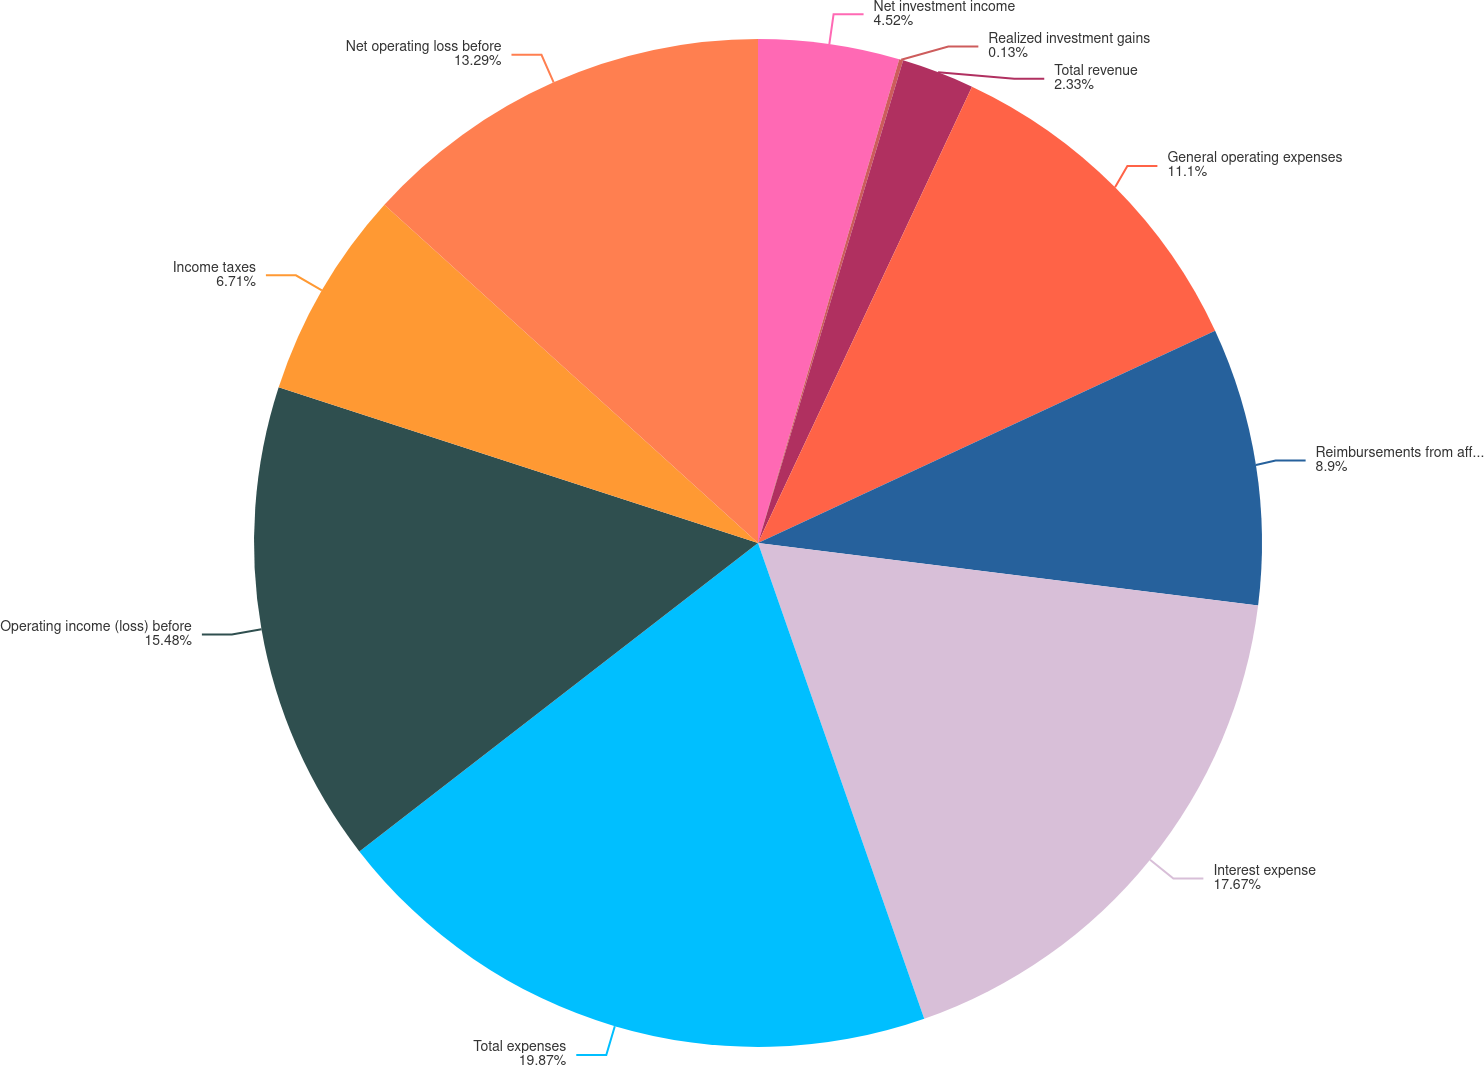Convert chart to OTSL. <chart><loc_0><loc_0><loc_500><loc_500><pie_chart><fcel>Net investment income<fcel>Realized investment gains<fcel>Total revenue<fcel>General operating expenses<fcel>Reimbursements from affiliates<fcel>Interest expense<fcel>Total expenses<fcel>Operating income (loss) before<fcel>Income taxes<fcel>Net operating loss before<nl><fcel>4.52%<fcel>0.13%<fcel>2.33%<fcel>11.1%<fcel>8.9%<fcel>17.67%<fcel>19.87%<fcel>15.48%<fcel>6.71%<fcel>13.29%<nl></chart> 